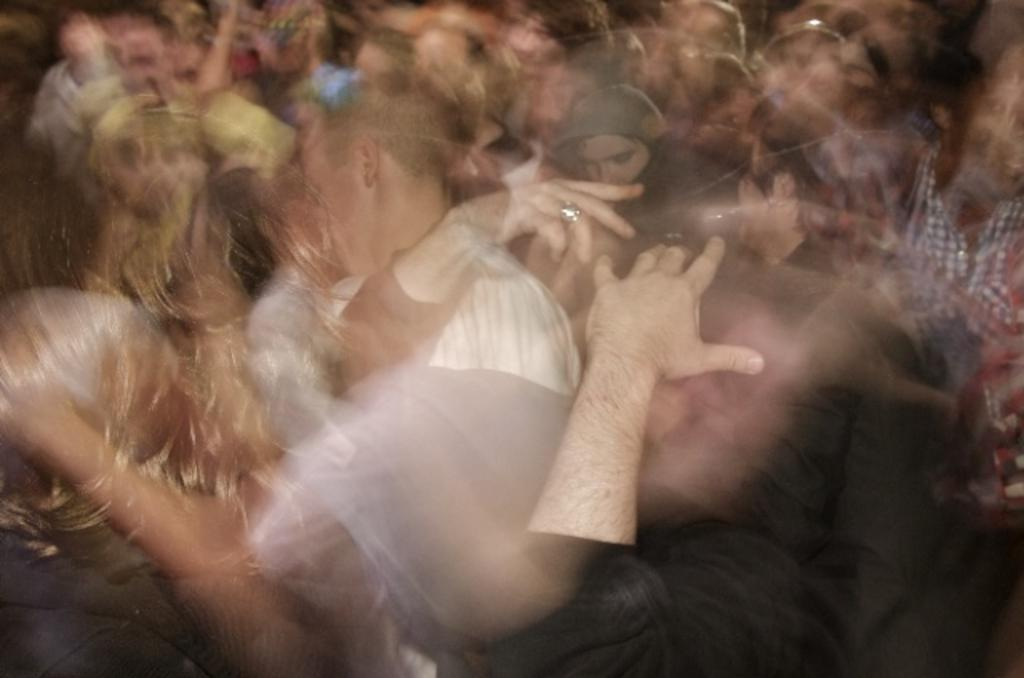What is the quality of the image? The image is a little blurred. Has the image been altered in any way? Yes, the image is an edited image. Can you identify any subjects in the image? Yes, there are people in the image. What type of yam is being peeled by the people in the image? There is no yam present in the image, nor are any people shown peeling a yam. What is the reaction of the people in the image to the sheet? There is no sheet present in the image, nor are any people shown reacting to a sheet. 